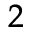<formula> <loc_0><loc_0><loc_500><loc_500>_ { 2 }</formula> 